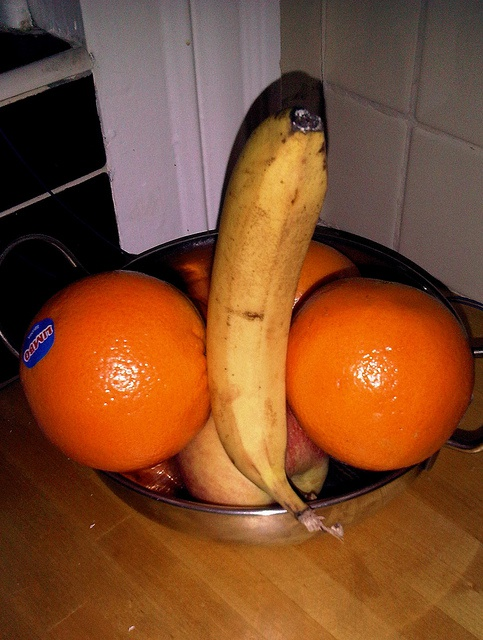Describe the objects in this image and their specific colors. I can see dining table in black, brown, and maroon tones, banana in black, orange, and olive tones, orange in black, red, brown, and maroon tones, orange in black, red, brown, and maroon tones, and bowl in black, maroon, and brown tones in this image. 